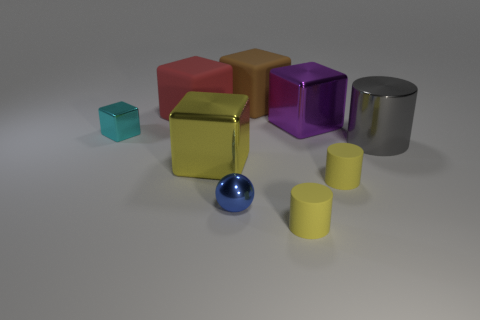There is a brown matte object; is it the same shape as the large matte thing left of the brown block?
Your answer should be compact. Yes. There is a tiny metal object that is behind the big yellow object; does it have the same shape as the big purple metal object?
Offer a terse response. Yes. Are there any cyan metallic things that have the same shape as the large brown matte object?
Provide a succinct answer. Yes. What number of objects are small things behind the big yellow object or rubber objects to the right of the red matte thing?
Your answer should be very brief. 4. There is a large cube on the left side of the big shiny cube that is in front of the tiny cyan object; what color is it?
Keep it short and to the point. Red. The large cylinder that is made of the same material as the small cyan thing is what color?
Your answer should be very brief. Gray. How many objects are small yellow shiny spheres or large rubber blocks?
Provide a succinct answer. 2. There is a red object that is the same size as the metal cylinder; what shape is it?
Provide a succinct answer. Cube. What number of large cubes are behind the purple cube and in front of the small cyan block?
Ensure brevity in your answer.  0. There is a yellow cylinder on the left side of the big purple cube; what is it made of?
Your answer should be very brief. Rubber. 